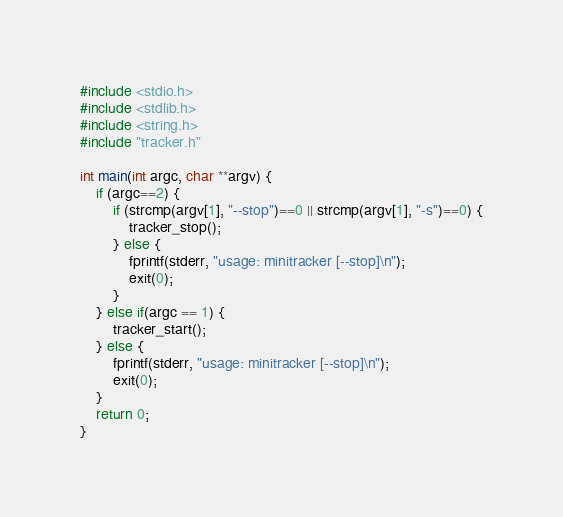<code> <loc_0><loc_0><loc_500><loc_500><_C_>#include <stdio.h>
#include <stdlib.h>
#include <string.h>
#include "tracker.h"

int main(int argc, char **argv) {
    if (argc==2) {
        if (strcmp(argv[1], "--stop")==0 || strcmp(argv[1], "-s")==0) {
            tracker_stop();
        } else {
            fprintf(stderr, "usage: minitracker [--stop]\n");
            exit(0);
        }
    } else if(argc == 1) {
        tracker_start();
    } else {
        fprintf(stderr, "usage: minitracker [--stop]\n");
        exit(0);
    }
    return 0;
}
</code> 